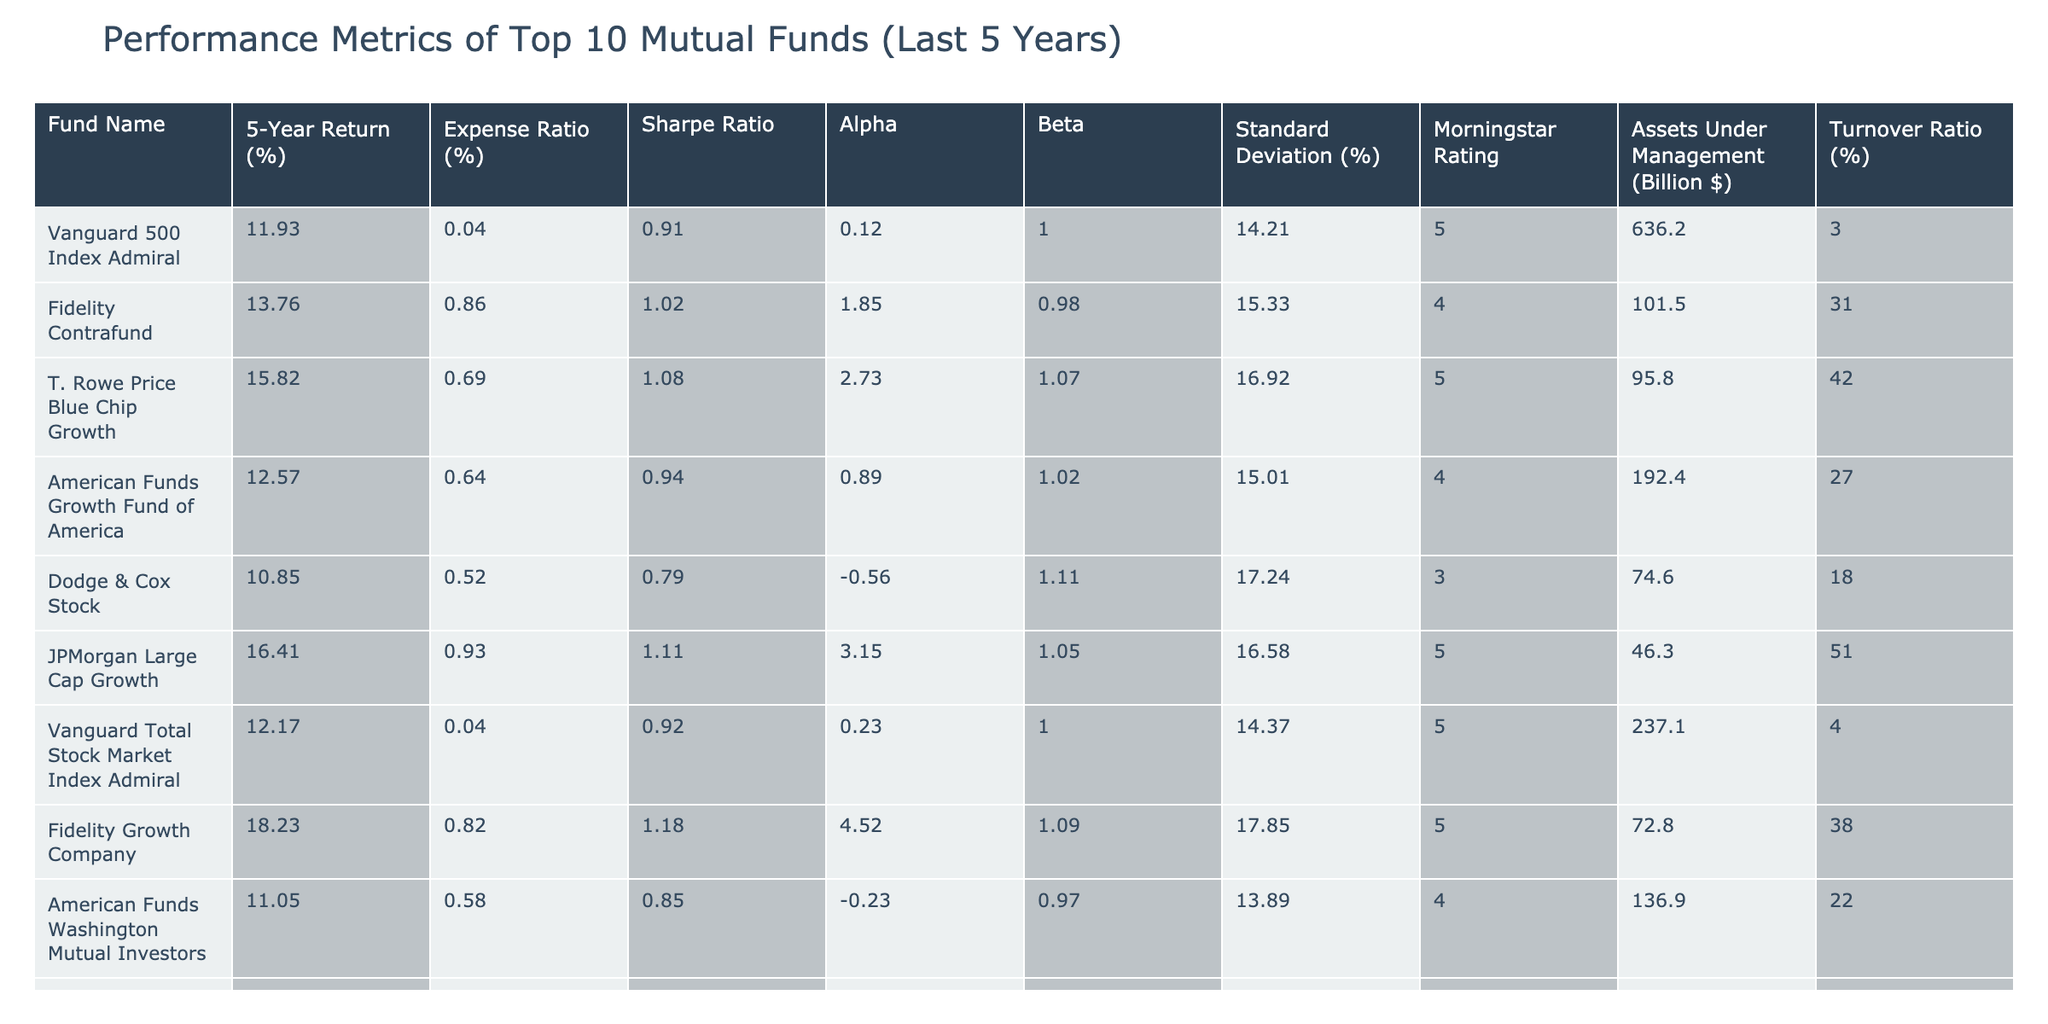What is the 5-year return of Fidelity Contrafund? The table shows the 5-year return for Fidelity Contrafund as 13.76%.
Answer: 13.76% Which fund has the lowest expense ratio? The expense ratio for each fund is listed in the table. The lowest is for Vanguard 500 Index Admiral at 0.04%.
Answer: 0.04% What is the Sharpe ratio of T. Rowe Price Blue Chip Growth? The table indicates that T. Rowe Price Blue Chip Growth has a Sharpe ratio of 1.08.
Answer: 1.08 Which mutual fund has the highest assets under management? By checking the "Assets Under Management" column, we can see that Vanguard 500 Index Admiral has the highest at 636.2 billion dollars.
Answer: 636.2 billion dollars What is the average 5-year return of the funds listed? Summing all 5-year returns (11.93 + 13.76 + 15.82 + 12.57 + 10.85 + 16.41 + 12.17 + 18.23 + 11.05 + 3.42) = 144.19, and dividing by 10 funds gives an average of 14.42%.
Answer: 14.42% Are there any funds with a 5-year return above 15%? Checking the 5-year return column, T. Rowe Price Blue Chip Growth, Fidelity Growth Company, and JPMorgan Large Cap Growth are all above 15%. Therefore, yes, there are funds with returns above this threshold.
Answer: Yes Which fund has the highest standard deviation? The highest standard deviation is located by evaluating the "Standard Deviation" column, and it belongs to Dodge & Cox Stock at 17.24%.
Answer: 17.24% Is the alpha of American Funds Washington Mutual Investors positive? The alpha value for American Funds Washington Mutual Investors is -0.23%, which is negative. Therefore, the answer is no.
Answer: No What is the difference between the highest and lowest Sharpe ratios among these funds? The highest Sharpe ratio is 1.18 (Fidelity Growth Company) and the lowest is 0.61 (PIMCO Total Return), so the difference is 1.18 - 0.61 = 0.57.
Answer: 0.57 Which fund has a higher expense ratio: JPMorgan Large Cap Growth or Dodge & Cox Stock? Comparing the expense ratios, JPMorgan Large Cap Growth has 0.93% while Dodge & Cox Stock has 0.52%, indicating JPMorgan has a higher expense ratio.
Answer: JPMorgan Large Cap Growth 